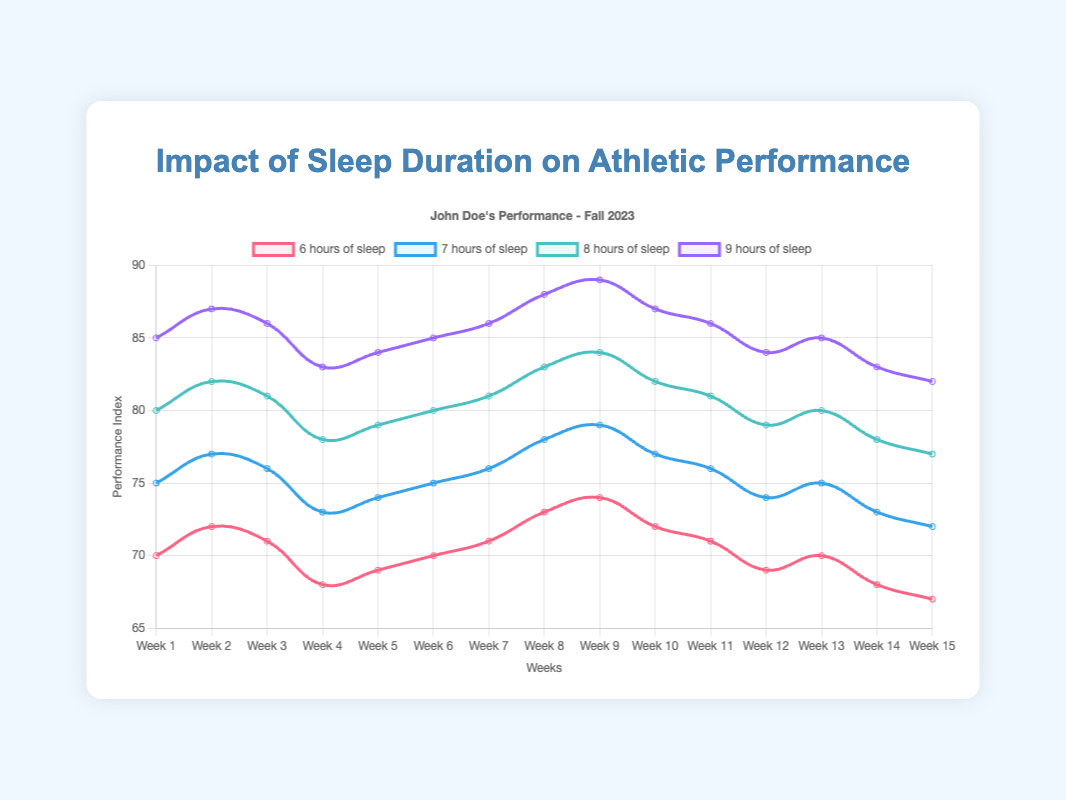What is the performance index difference between getting 6 hours and 9 hours of sleep in Week 1? The performance index with 6 hours of sleep in Week 1 is 70, while with 9 hours of sleep, it is 85. The difference is 85 - 70 = 15.
Answer: 15 How does the performance index change over time with 7 hours of sleep from Week 1 to Week 15? To determine the change, observe the performance index at Week 1 which is 75 and at Week 15 which is 72. The change is 72 - 75 = -3.
Answer: -3 In which week does the performance index for 8 hours of sleep reach its peak value? Looking at the plot, the performance index for 8 hours of sleep reaches its highest value in Week 9 with a value of 84.
Answer: Week 9 How does the performance index at Week 5 compare among the different sleep durations? For Week 5, the performance indices are: 6 hours - 69, 7 hours - 74, 8 hours - 79, 9 hours - 84. Comparing these values, the performance increases with more sleep.
Answer: Increases with more sleep What is the average performance index for 9 hours of sleep across the semester? To calculate the average, sum the performance indices and divide by the number of weeks. (85 + 87 + 86 + 83 + 84 + 85 + 86 + 88 + 89 + 87 + 86 + 84 + 85 + 83 + 82)/15 = 84.47.
Answer: 84.47 Which sleep duration shows the most consistent (least fluctuating) performance index across the semester? To determine this, look at the variation in performance indices for each sleep duration. 7, 8, and 9 hours have minimal variation, while 6 hours has more fluctuation. The performance indices for 9 hours sleep are closely packed together.
Answer: 9 hours At what point does the performance index for 6 hours of sleep fall below 70? Observing the plot, the performance index for 6 hours of sleep falls below 70 at Week 4 with a value of 68 and stays below for multiple weeks.
Answer: Week 4 How much higher is the performance index for 8 hours of sleep compared to 7 hours of sleep in Week 10? The performance index for 8 hours of sleep in Week 10 is 82, while it is 77 for 7 hours of sleep. The difference is 82 - 77 = 5.
Answer: 5 Looking just at Week 12, which sleep duration improves the performance index the most compared to Week 1? Comparing Week 12 to Week 1: 6 hours (69 - 70 = -1), 7 hours (74 - 75 = -1), 8 hours (79 - 80 = -1), 9 hours (84 - 85 = -1). All sleep durations have improved performance indexes by the same magnitude.
Answer: All sleep durations have the same improvement Is there a noticeable downward trend in performance index for any sleep duration from Week 1 to Week 15? Observing the plot, the performance index for 6 hours and 7 hours of sleep shows a noticeable downward trend from Week 1 to Week 15.
Answer: 6 hours and 7 hours 